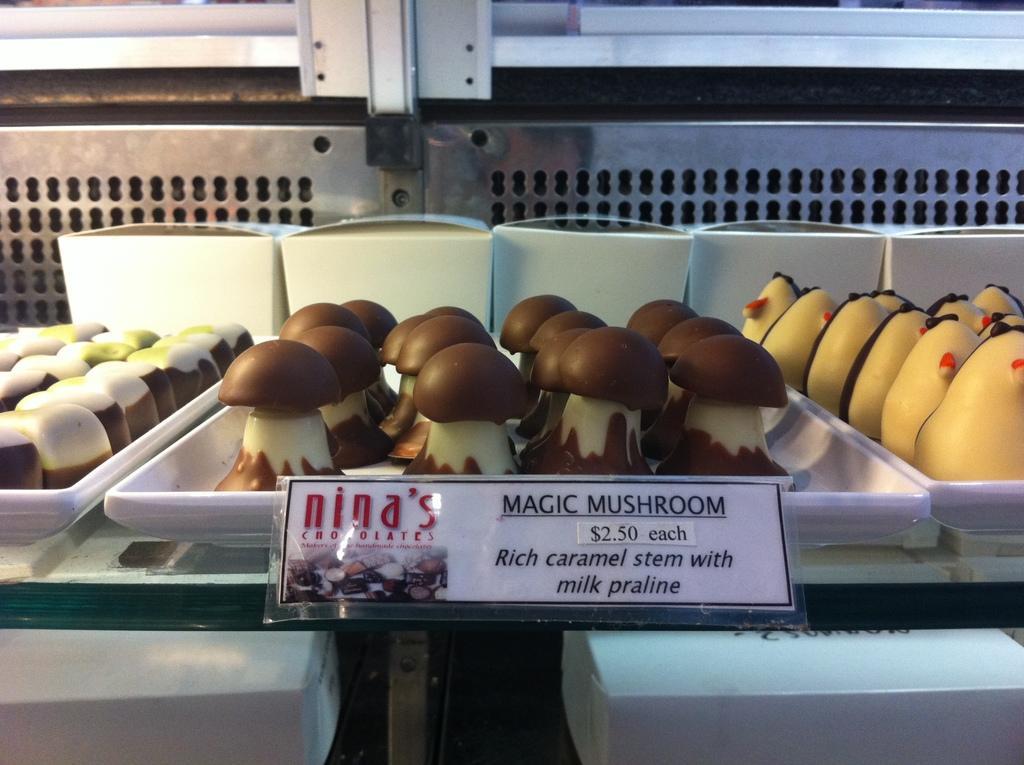Could you give a brief overview of what you see in this image? In the image we can see there are many tray, white in color. In the tray there are food items of different color and shape. This is a name and price tag. 